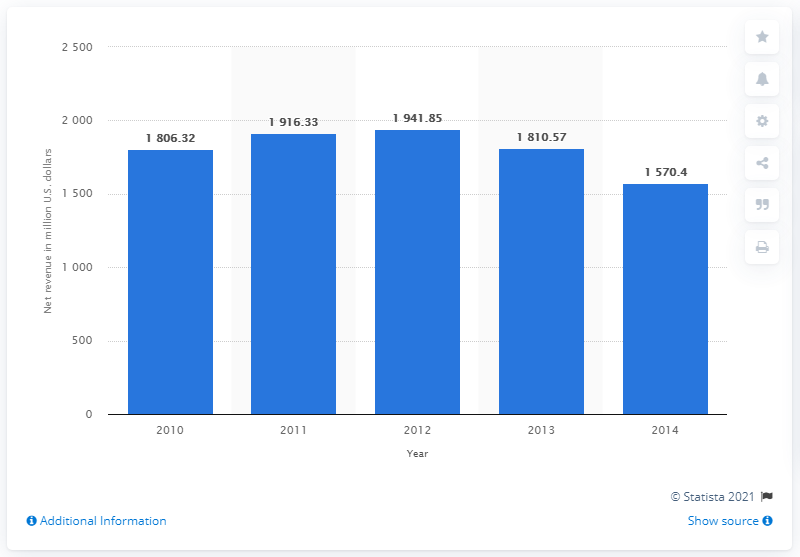Draw attention to some important aspects in this diagram. In 2014, Quiksilver's global net revenue was $1,570.4 million. 